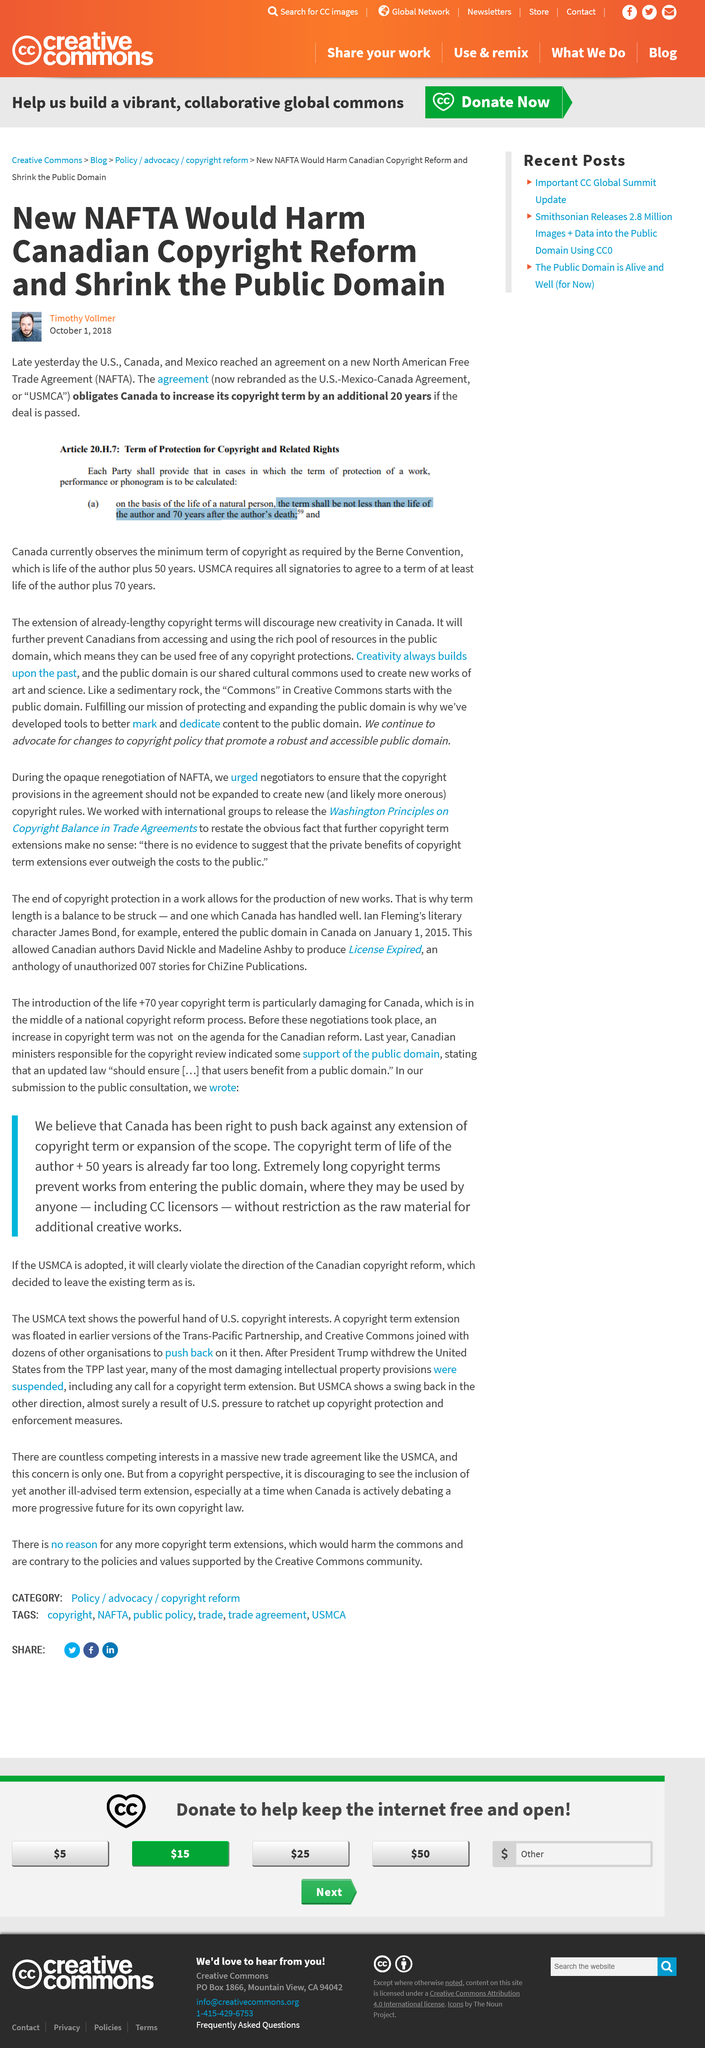Outline some significant characteristics in this image. This article was written on October 1, 2018, and it provides information about the history of the term 'hacker.' The acronym "NAFTA" stands for the North American Free Trade Agreement, which is a treaty between the governments of Canada, Mexico, and the United States that aims to promote free trade and economic integration among the three countries. The article discussing the negative impact of NAFTA on Canadian copyright reform was written by Timothy Vollmer. 